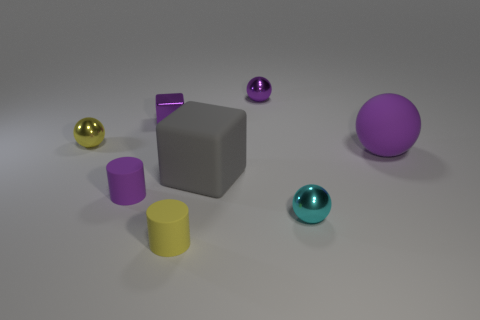There is a small purple thing that is in front of the yellow thing behind the cyan thing; what shape is it?
Provide a short and direct response. Cylinder. What number of small red things have the same material as the gray thing?
Give a very brief answer. 0. The other large thing that is the same material as the big purple thing is what color?
Offer a very short reply. Gray. There is a metallic sphere on the left side of the big gray cube that is to the left of the tiny metallic thing in front of the purple rubber ball; how big is it?
Make the answer very short. Small. Is the number of purple shiny spheres less than the number of metal objects?
Offer a very short reply. Yes. There is another tiny thing that is the same shape as the small purple matte thing; what is its color?
Make the answer very short. Yellow. Are there any small cylinders that are on the right side of the small yellow object that is on the right side of the small yellow thing that is behind the tiny cyan metal thing?
Make the answer very short. No. Is the cyan shiny object the same shape as the big purple matte object?
Provide a short and direct response. Yes. Is the number of big balls behind the purple matte sphere less than the number of purple metal spheres?
Offer a terse response. Yes. There is a shiny ball left of the cube that is on the right side of the cube that is behind the gray matte object; what color is it?
Give a very brief answer. Yellow. 